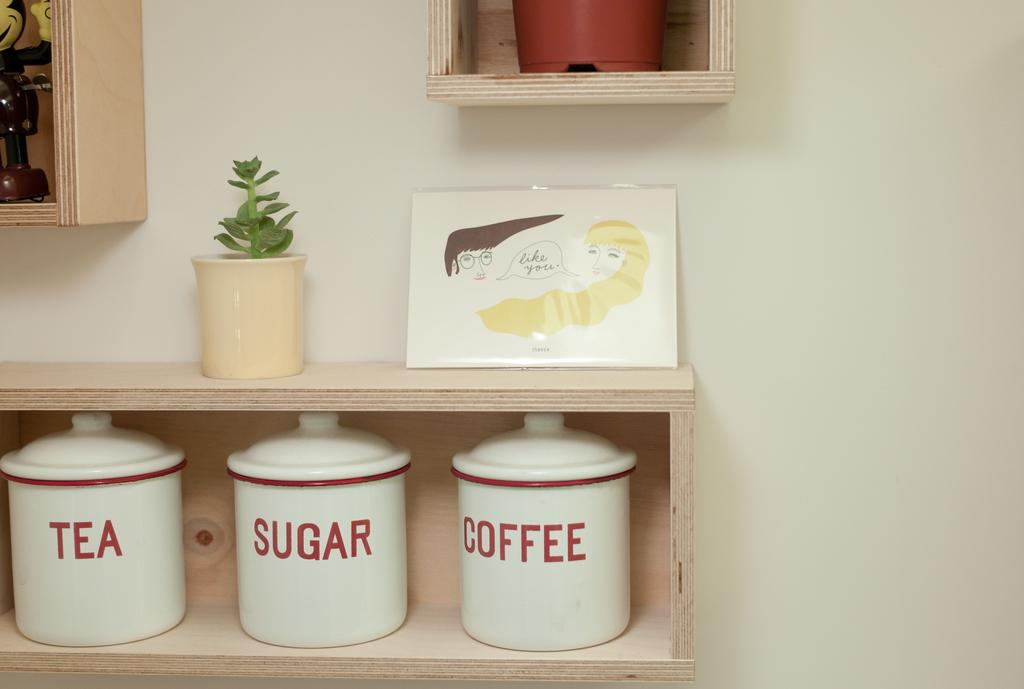<image>
Relay a brief, clear account of the picture shown. On a plain beech box shelf stand three white canisters with red writing, which contain tea, coffee and sugar. 